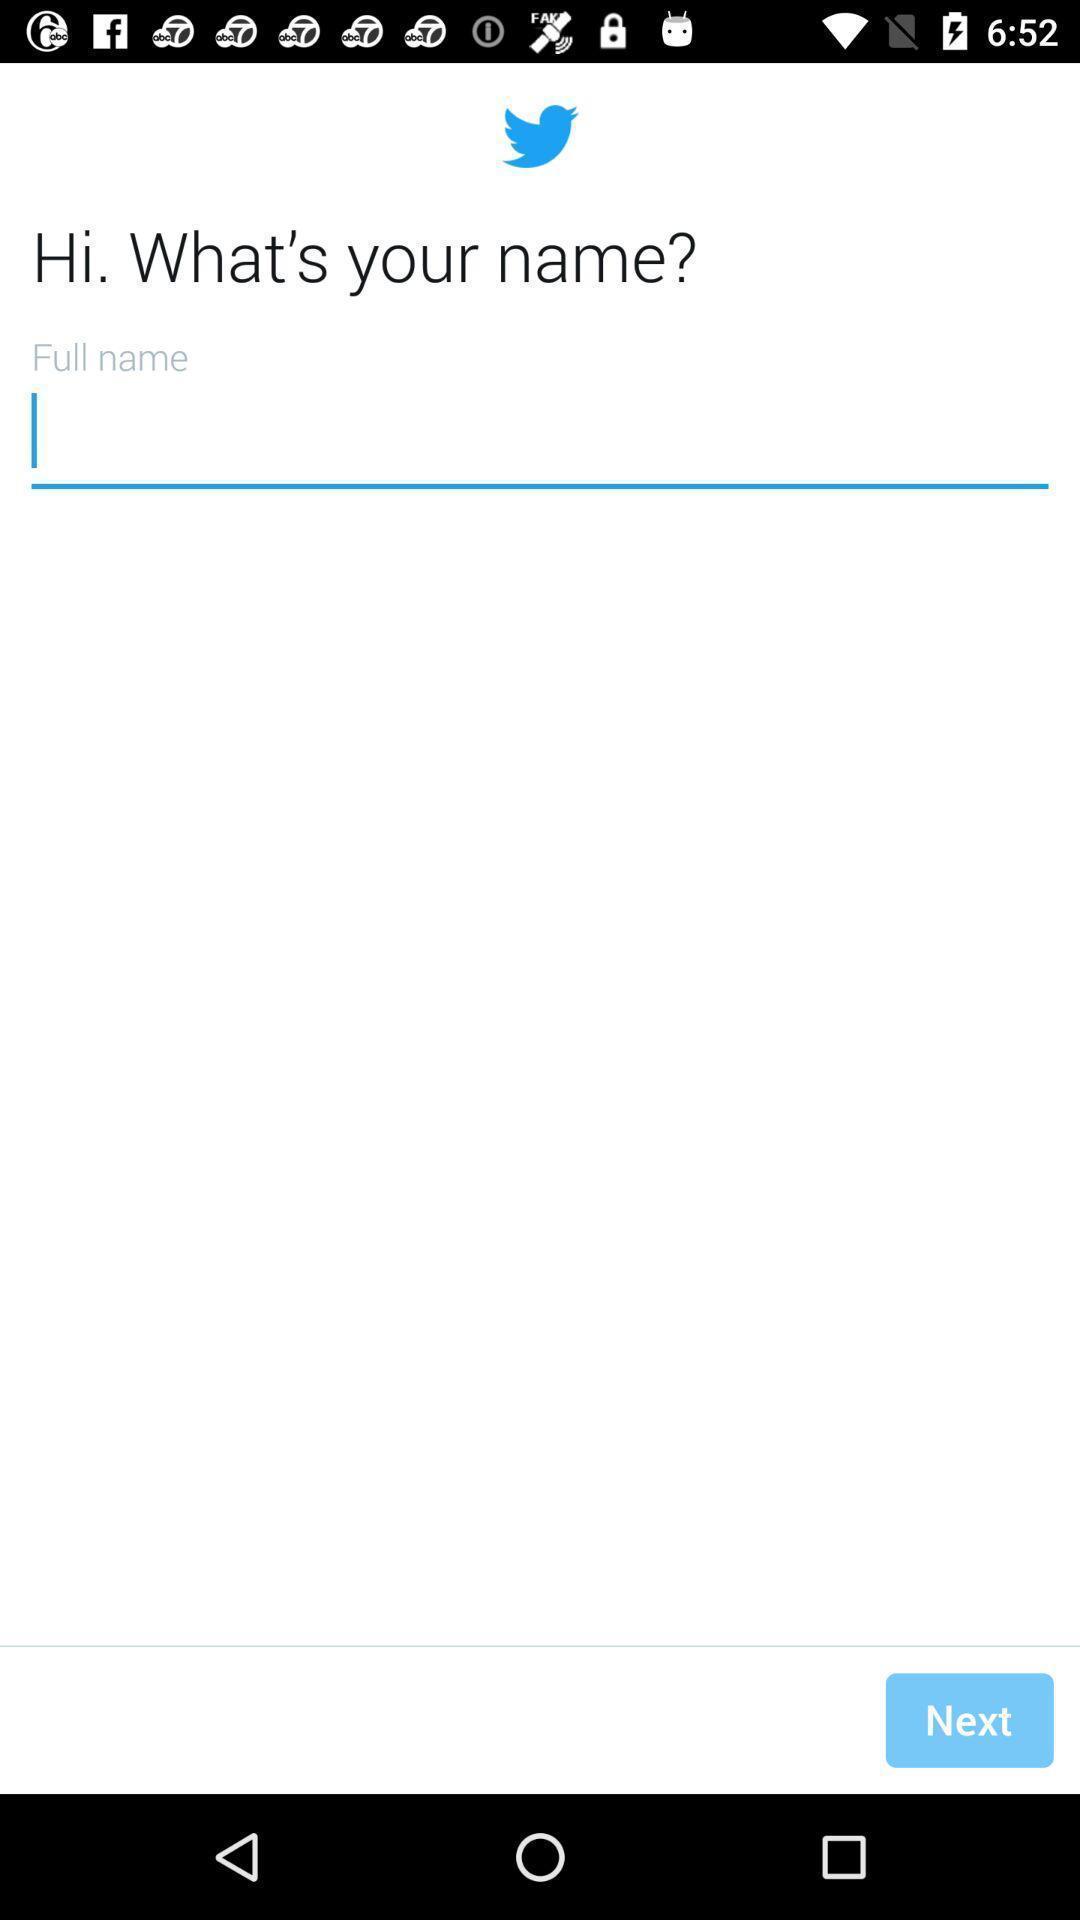Describe the content in this image. Starting page for the social media app. 